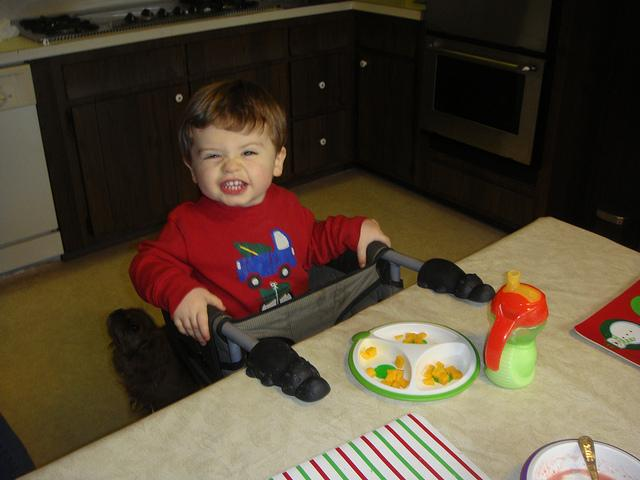What kind of plate is the boy using? Please explain your reasoning. divider. A kid is sitting in front of a plate that is sectioned of into areas so the food doesn't touch. 